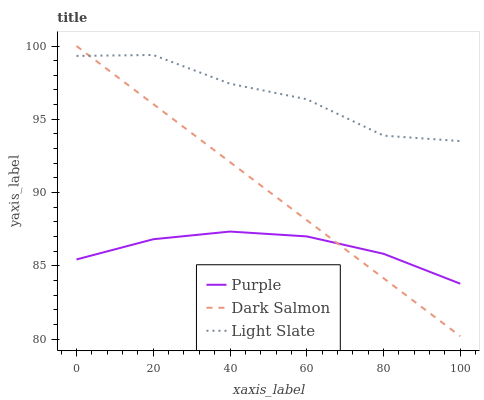Does Purple have the minimum area under the curve?
Answer yes or no. Yes. Does Light Slate have the maximum area under the curve?
Answer yes or no. Yes. Does Dark Salmon have the minimum area under the curve?
Answer yes or no. No. Does Dark Salmon have the maximum area under the curve?
Answer yes or no. No. Is Dark Salmon the smoothest?
Answer yes or no. Yes. Is Light Slate the roughest?
Answer yes or no. Yes. Is Light Slate the smoothest?
Answer yes or no. No. Is Dark Salmon the roughest?
Answer yes or no. No. Does Dark Salmon have the lowest value?
Answer yes or no. Yes. Does Light Slate have the lowest value?
Answer yes or no. No. Does Dark Salmon have the highest value?
Answer yes or no. Yes. Does Light Slate have the highest value?
Answer yes or no. No. Is Purple less than Light Slate?
Answer yes or no. Yes. Is Light Slate greater than Purple?
Answer yes or no. Yes. Does Dark Salmon intersect Purple?
Answer yes or no. Yes. Is Dark Salmon less than Purple?
Answer yes or no. No. Is Dark Salmon greater than Purple?
Answer yes or no. No. Does Purple intersect Light Slate?
Answer yes or no. No. 